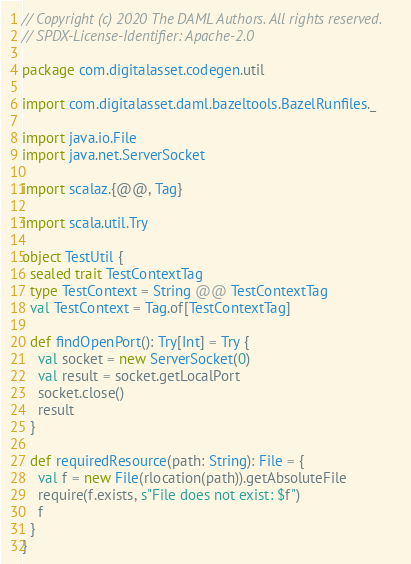Convert code to text. <code><loc_0><loc_0><loc_500><loc_500><_Scala_>// Copyright (c) 2020 The DAML Authors. All rights reserved.
// SPDX-License-Identifier: Apache-2.0

package com.digitalasset.codegen.util

import com.digitalasset.daml.bazeltools.BazelRunfiles._

import java.io.File
import java.net.ServerSocket

import scalaz.{@@, Tag}

import scala.util.Try

object TestUtil {
  sealed trait TestContextTag
  type TestContext = String @@ TestContextTag
  val TestContext = Tag.of[TestContextTag]

  def findOpenPort(): Try[Int] = Try {
    val socket = new ServerSocket(0)
    val result = socket.getLocalPort
    socket.close()
    result
  }

  def requiredResource(path: String): File = {
    val f = new File(rlocation(path)).getAbsoluteFile
    require(f.exists, s"File does not exist: $f")
    f
  }
}
</code> 